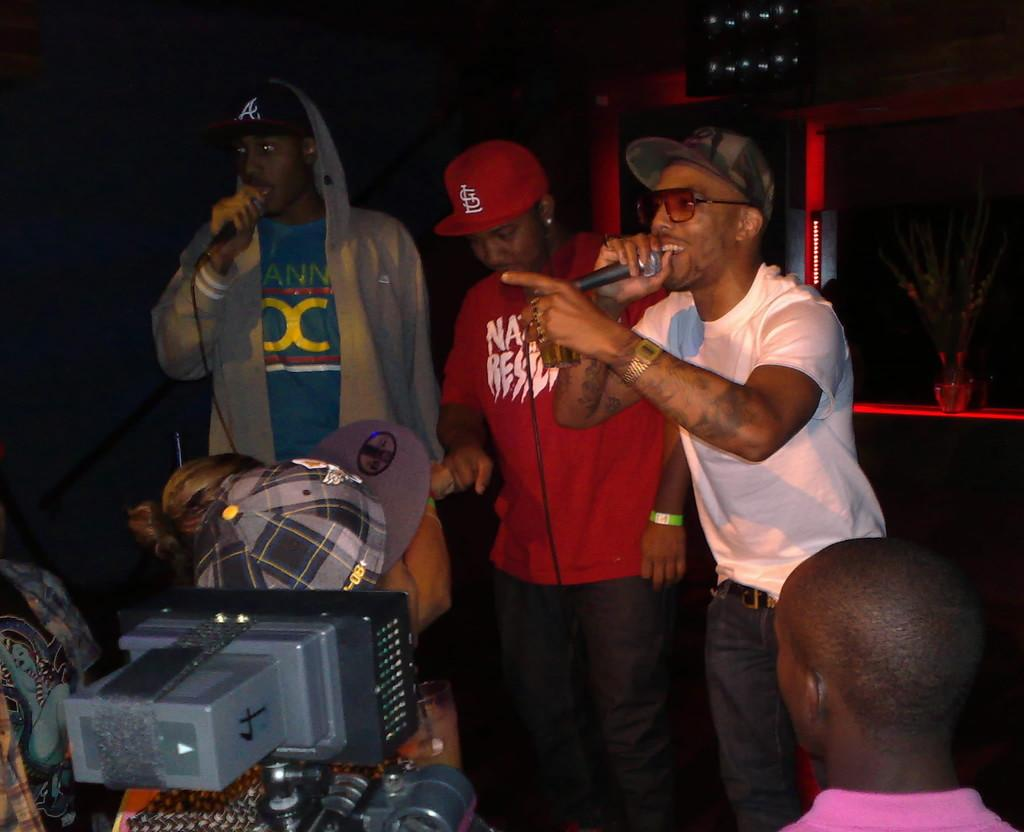What is the man in the image doing? The man is singing in the image. What is the man holding while singing? The man is holding a microphone. Can you describe the man's clothing in the image? The man is wearing a t-shirt, spectacles, and a cap. Are there any other people in the image? Yes, there is another man in the image. What is the second man holding? The second man is also holding a microphone. What type of metal is used to make the hospital bed in the image? There is no hospital bed present in the image, and therefore no metal can be identified. 